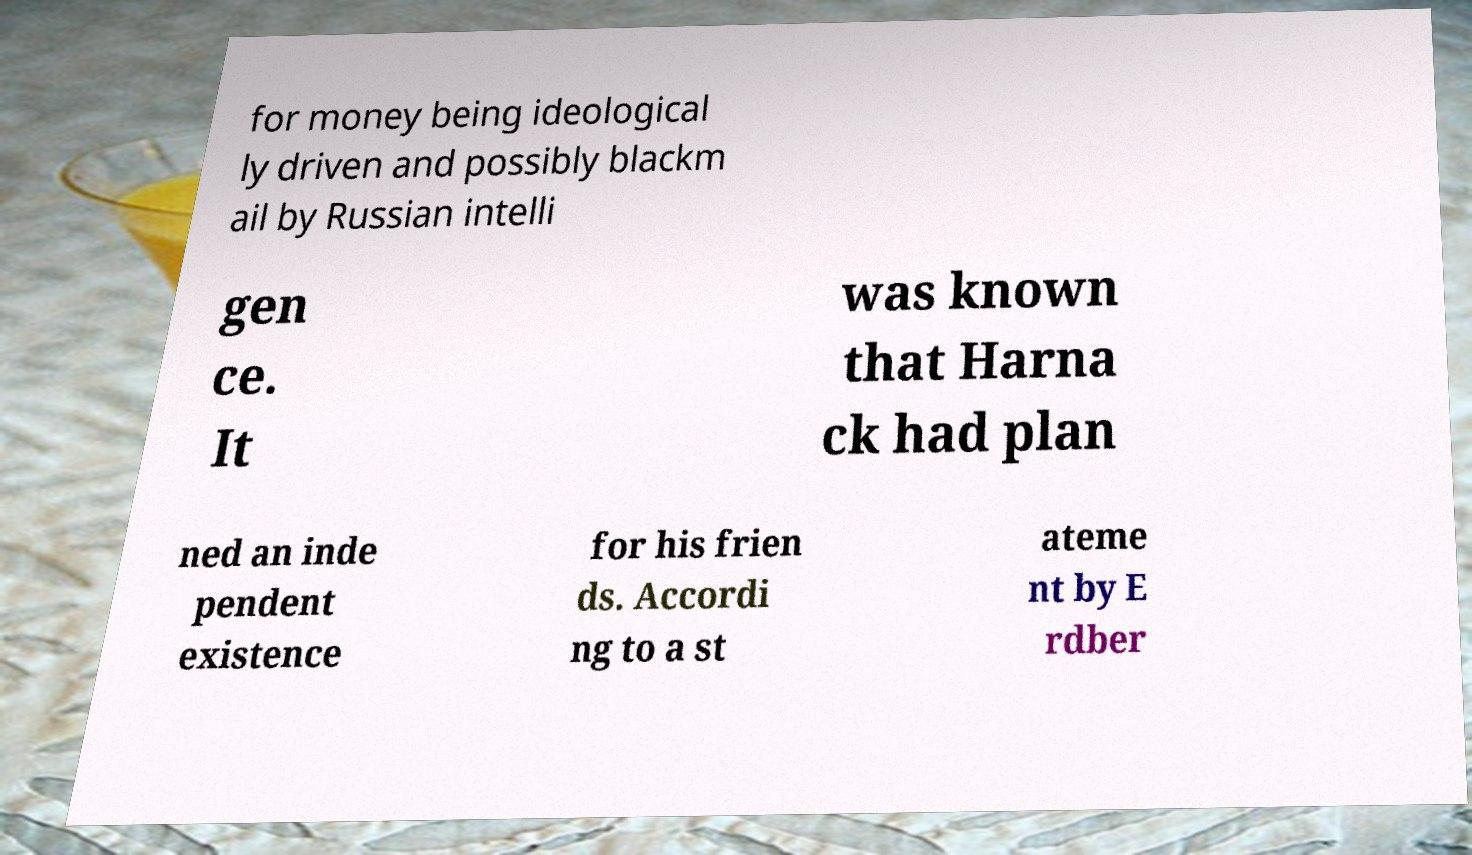What messages or text are displayed in this image? I need them in a readable, typed format. for money being ideological ly driven and possibly blackm ail by Russian intelli gen ce. It was known that Harna ck had plan ned an inde pendent existence for his frien ds. Accordi ng to a st ateme nt by E rdber 